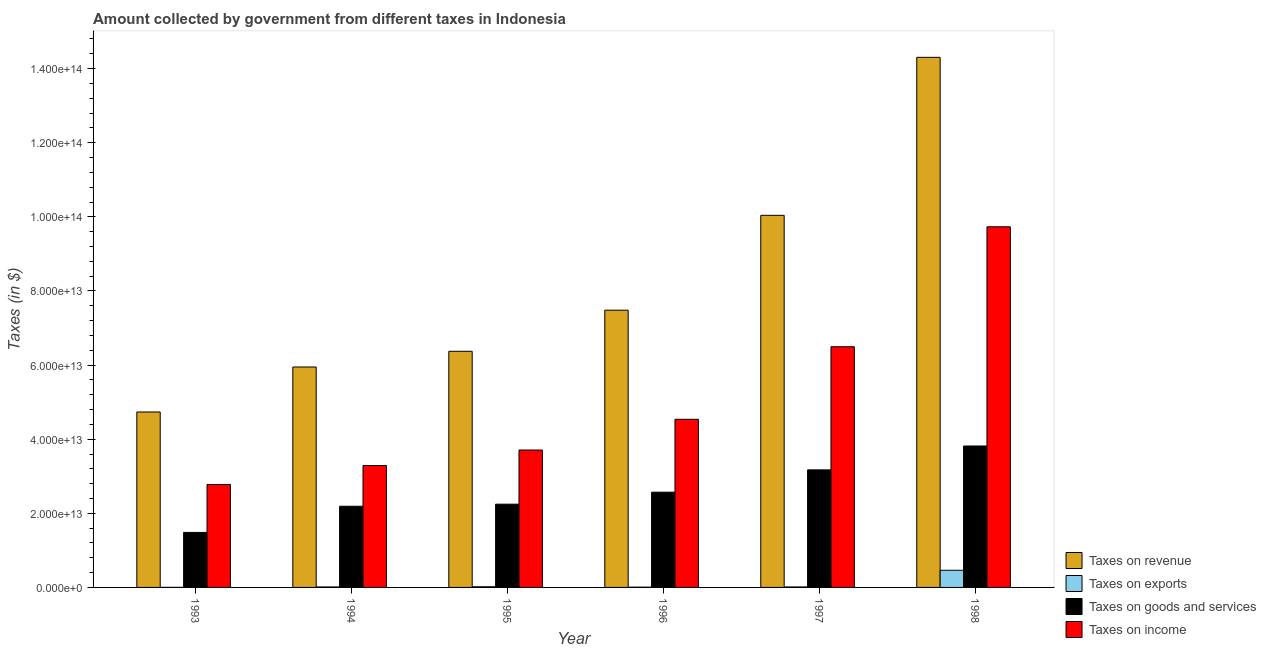How many bars are there on the 6th tick from the left?
Offer a terse response. 4. In how many cases, is the number of bars for a given year not equal to the number of legend labels?
Make the answer very short. 0. What is the amount collected as tax on income in 1994?
Keep it short and to the point. 3.29e+13. Across all years, what is the maximum amount collected as tax on revenue?
Offer a very short reply. 1.43e+14. Across all years, what is the minimum amount collected as tax on income?
Offer a terse response. 2.78e+13. What is the total amount collected as tax on goods in the graph?
Offer a very short reply. 1.55e+14. What is the difference between the amount collected as tax on revenue in 1996 and that in 1998?
Give a very brief answer. -6.82e+13. What is the difference between the amount collected as tax on goods in 1995 and the amount collected as tax on exports in 1998?
Ensure brevity in your answer.  -1.57e+13. What is the average amount collected as tax on income per year?
Offer a very short reply. 5.09e+13. In the year 1998, what is the difference between the amount collected as tax on exports and amount collected as tax on revenue?
Ensure brevity in your answer.  0. In how many years, is the amount collected as tax on revenue greater than 108000000000000 $?
Your answer should be very brief. 1. What is the ratio of the amount collected as tax on goods in 1993 to that in 1995?
Provide a short and direct response. 0.66. What is the difference between the highest and the second highest amount collected as tax on exports?
Keep it short and to the point. 4.44e+12. What is the difference between the highest and the lowest amount collected as tax on revenue?
Offer a terse response. 9.57e+13. Is the sum of the amount collected as tax on goods in 1993 and 1996 greater than the maximum amount collected as tax on income across all years?
Your response must be concise. Yes. Is it the case that in every year, the sum of the amount collected as tax on goods and amount collected as tax on revenue is greater than the sum of amount collected as tax on income and amount collected as tax on exports?
Offer a terse response. No. What does the 4th bar from the left in 1994 represents?
Make the answer very short. Taxes on income. What does the 3rd bar from the right in 1997 represents?
Your answer should be very brief. Taxes on exports. Is it the case that in every year, the sum of the amount collected as tax on revenue and amount collected as tax on exports is greater than the amount collected as tax on goods?
Offer a very short reply. Yes. How many bars are there?
Offer a terse response. 24. How many years are there in the graph?
Your answer should be very brief. 6. What is the difference between two consecutive major ticks on the Y-axis?
Your response must be concise. 2.00e+13. Are the values on the major ticks of Y-axis written in scientific E-notation?
Provide a short and direct response. Yes. Does the graph contain any zero values?
Provide a succinct answer. No. Does the graph contain grids?
Your answer should be compact. No. Where does the legend appear in the graph?
Ensure brevity in your answer.  Bottom right. How many legend labels are there?
Keep it short and to the point. 4. How are the legend labels stacked?
Make the answer very short. Vertical. What is the title of the graph?
Give a very brief answer. Amount collected by government from different taxes in Indonesia. What is the label or title of the Y-axis?
Offer a very short reply. Taxes (in $). What is the Taxes (in $) in Taxes on revenue in 1993?
Ensure brevity in your answer.  4.73e+13. What is the Taxes (in $) of Taxes on exports in 1993?
Your response must be concise. 1.40e+1. What is the Taxes (in $) of Taxes on goods and services in 1993?
Your answer should be compact. 1.48e+13. What is the Taxes (in $) of Taxes on income in 1993?
Your response must be concise. 2.78e+13. What is the Taxes (in $) in Taxes on revenue in 1994?
Ensure brevity in your answer.  5.95e+13. What is the Taxes (in $) of Taxes on exports in 1994?
Ensure brevity in your answer.  1.31e+11. What is the Taxes (in $) in Taxes on goods and services in 1994?
Provide a succinct answer. 2.19e+13. What is the Taxes (in $) of Taxes on income in 1994?
Keep it short and to the point. 3.29e+13. What is the Taxes (in $) of Taxes on revenue in 1995?
Offer a very short reply. 6.37e+13. What is the Taxes (in $) of Taxes on exports in 1995?
Keep it short and to the point. 1.86e+11. What is the Taxes (in $) of Taxes on goods and services in 1995?
Ensure brevity in your answer.  2.25e+13. What is the Taxes (in $) in Taxes on income in 1995?
Provide a succinct answer. 3.71e+13. What is the Taxes (in $) of Taxes on revenue in 1996?
Offer a terse response. 7.48e+13. What is the Taxes (in $) of Taxes on exports in 1996?
Make the answer very short. 7.00e+1. What is the Taxes (in $) of Taxes on goods and services in 1996?
Make the answer very short. 2.57e+13. What is the Taxes (in $) of Taxes on income in 1996?
Make the answer very short. 4.54e+13. What is the Taxes (in $) of Taxes on revenue in 1997?
Your response must be concise. 1.00e+14. What is the Taxes (in $) of Taxes on exports in 1997?
Your answer should be compact. 1.28e+11. What is the Taxes (in $) in Taxes on goods and services in 1997?
Give a very brief answer. 3.17e+13. What is the Taxes (in $) of Taxes on income in 1997?
Ensure brevity in your answer.  6.49e+13. What is the Taxes (in $) in Taxes on revenue in 1998?
Your response must be concise. 1.43e+14. What is the Taxes (in $) of Taxes on exports in 1998?
Make the answer very short. 4.63e+12. What is the Taxes (in $) in Taxes on goods and services in 1998?
Make the answer very short. 3.82e+13. What is the Taxes (in $) of Taxes on income in 1998?
Your response must be concise. 9.73e+13. Across all years, what is the maximum Taxes (in $) in Taxes on revenue?
Give a very brief answer. 1.43e+14. Across all years, what is the maximum Taxes (in $) in Taxes on exports?
Your response must be concise. 4.63e+12. Across all years, what is the maximum Taxes (in $) in Taxes on goods and services?
Ensure brevity in your answer.  3.82e+13. Across all years, what is the maximum Taxes (in $) in Taxes on income?
Offer a terse response. 9.73e+13. Across all years, what is the minimum Taxes (in $) of Taxes on revenue?
Your answer should be very brief. 4.73e+13. Across all years, what is the minimum Taxes (in $) in Taxes on exports?
Keep it short and to the point. 1.40e+1. Across all years, what is the minimum Taxes (in $) of Taxes on goods and services?
Provide a succinct answer. 1.48e+13. Across all years, what is the minimum Taxes (in $) of Taxes on income?
Make the answer very short. 2.78e+13. What is the total Taxes (in $) in Taxes on revenue in the graph?
Keep it short and to the point. 4.89e+14. What is the total Taxes (in $) in Taxes on exports in the graph?
Offer a very short reply. 5.16e+12. What is the total Taxes (in $) in Taxes on goods and services in the graph?
Offer a very short reply. 1.55e+14. What is the total Taxes (in $) in Taxes on income in the graph?
Your answer should be very brief. 3.05e+14. What is the difference between the Taxes (in $) in Taxes on revenue in 1993 and that in 1994?
Your response must be concise. -1.21e+13. What is the difference between the Taxes (in $) in Taxes on exports in 1993 and that in 1994?
Your answer should be compact. -1.17e+11. What is the difference between the Taxes (in $) in Taxes on goods and services in 1993 and that in 1994?
Provide a succinct answer. -7.06e+12. What is the difference between the Taxes (in $) of Taxes on income in 1993 and that in 1994?
Your answer should be very brief. -5.11e+12. What is the difference between the Taxes (in $) of Taxes on revenue in 1993 and that in 1995?
Offer a very short reply. -1.64e+13. What is the difference between the Taxes (in $) of Taxes on exports in 1993 and that in 1995?
Your answer should be compact. -1.72e+11. What is the difference between the Taxes (in $) of Taxes on goods and services in 1993 and that in 1995?
Your answer should be compact. -7.62e+12. What is the difference between the Taxes (in $) of Taxes on income in 1993 and that in 1995?
Keep it short and to the point. -9.30e+12. What is the difference between the Taxes (in $) of Taxes on revenue in 1993 and that in 1996?
Offer a very short reply. -2.75e+13. What is the difference between the Taxes (in $) of Taxes on exports in 1993 and that in 1996?
Keep it short and to the point. -5.60e+1. What is the difference between the Taxes (in $) of Taxes on goods and services in 1993 and that in 1996?
Provide a short and direct response. -1.09e+13. What is the difference between the Taxes (in $) in Taxes on income in 1993 and that in 1996?
Your response must be concise. -1.76e+13. What is the difference between the Taxes (in $) of Taxes on revenue in 1993 and that in 1997?
Make the answer very short. -5.31e+13. What is the difference between the Taxes (in $) in Taxes on exports in 1993 and that in 1997?
Your answer should be compact. -1.14e+11. What is the difference between the Taxes (in $) in Taxes on goods and services in 1993 and that in 1997?
Ensure brevity in your answer.  -1.69e+13. What is the difference between the Taxes (in $) of Taxes on income in 1993 and that in 1997?
Provide a succinct answer. -3.72e+13. What is the difference between the Taxes (in $) in Taxes on revenue in 1993 and that in 1998?
Provide a short and direct response. -9.57e+13. What is the difference between the Taxes (in $) of Taxes on exports in 1993 and that in 1998?
Your answer should be compact. -4.62e+12. What is the difference between the Taxes (in $) in Taxes on goods and services in 1993 and that in 1998?
Your response must be concise. -2.33e+13. What is the difference between the Taxes (in $) of Taxes on income in 1993 and that in 1998?
Make the answer very short. -6.95e+13. What is the difference between the Taxes (in $) of Taxes on revenue in 1994 and that in 1995?
Your response must be concise. -4.24e+12. What is the difference between the Taxes (in $) of Taxes on exports in 1994 and that in 1995?
Provide a short and direct response. -5.50e+1. What is the difference between the Taxes (in $) of Taxes on goods and services in 1994 and that in 1995?
Offer a terse response. -5.60e+11. What is the difference between the Taxes (in $) in Taxes on income in 1994 and that in 1995?
Ensure brevity in your answer.  -4.18e+12. What is the difference between the Taxes (in $) in Taxes on revenue in 1994 and that in 1996?
Provide a short and direct response. -1.53e+13. What is the difference between the Taxes (in $) in Taxes on exports in 1994 and that in 1996?
Provide a short and direct response. 6.10e+1. What is the difference between the Taxes (in $) in Taxes on goods and services in 1994 and that in 1996?
Make the answer very short. -3.80e+12. What is the difference between the Taxes (in $) in Taxes on income in 1994 and that in 1996?
Offer a terse response. -1.25e+13. What is the difference between the Taxes (in $) in Taxes on revenue in 1994 and that in 1997?
Your response must be concise. -4.09e+13. What is the difference between the Taxes (in $) in Taxes on exports in 1994 and that in 1997?
Your answer should be very brief. 2.50e+09. What is the difference between the Taxes (in $) in Taxes on goods and services in 1994 and that in 1997?
Make the answer very short. -9.82e+12. What is the difference between the Taxes (in $) of Taxes on income in 1994 and that in 1997?
Ensure brevity in your answer.  -3.21e+13. What is the difference between the Taxes (in $) in Taxes on revenue in 1994 and that in 1998?
Your answer should be compact. -8.36e+13. What is the difference between the Taxes (in $) in Taxes on exports in 1994 and that in 1998?
Your response must be concise. -4.50e+12. What is the difference between the Taxes (in $) of Taxes on goods and services in 1994 and that in 1998?
Provide a short and direct response. -1.63e+13. What is the difference between the Taxes (in $) in Taxes on income in 1994 and that in 1998?
Offer a terse response. -6.44e+13. What is the difference between the Taxes (in $) of Taxes on revenue in 1995 and that in 1996?
Your answer should be very brief. -1.11e+13. What is the difference between the Taxes (in $) of Taxes on exports in 1995 and that in 1996?
Give a very brief answer. 1.16e+11. What is the difference between the Taxes (in $) in Taxes on goods and services in 1995 and that in 1996?
Provide a short and direct response. -3.24e+12. What is the difference between the Taxes (in $) of Taxes on income in 1995 and that in 1996?
Give a very brief answer. -8.29e+12. What is the difference between the Taxes (in $) of Taxes on revenue in 1995 and that in 1997?
Your answer should be compact. -3.67e+13. What is the difference between the Taxes (in $) in Taxes on exports in 1995 and that in 1997?
Your answer should be compact. 5.75e+1. What is the difference between the Taxes (in $) in Taxes on goods and services in 1995 and that in 1997?
Make the answer very short. -9.26e+12. What is the difference between the Taxes (in $) in Taxes on income in 1995 and that in 1997?
Provide a short and direct response. -2.79e+13. What is the difference between the Taxes (in $) of Taxes on revenue in 1995 and that in 1998?
Provide a short and direct response. -7.93e+13. What is the difference between the Taxes (in $) of Taxes on exports in 1995 and that in 1998?
Provide a short and direct response. -4.44e+12. What is the difference between the Taxes (in $) in Taxes on goods and services in 1995 and that in 1998?
Keep it short and to the point. -1.57e+13. What is the difference between the Taxes (in $) in Taxes on income in 1995 and that in 1998?
Your answer should be compact. -6.02e+13. What is the difference between the Taxes (in $) in Taxes on revenue in 1996 and that in 1997?
Offer a very short reply. -2.56e+13. What is the difference between the Taxes (in $) in Taxes on exports in 1996 and that in 1997?
Provide a succinct answer. -5.85e+1. What is the difference between the Taxes (in $) in Taxes on goods and services in 1996 and that in 1997?
Make the answer very short. -6.02e+12. What is the difference between the Taxes (in $) in Taxes on income in 1996 and that in 1997?
Ensure brevity in your answer.  -1.96e+13. What is the difference between the Taxes (in $) of Taxes on revenue in 1996 and that in 1998?
Make the answer very short. -6.82e+13. What is the difference between the Taxes (in $) in Taxes on exports in 1996 and that in 1998?
Offer a very short reply. -4.56e+12. What is the difference between the Taxes (in $) in Taxes on goods and services in 1996 and that in 1998?
Provide a succinct answer. -1.25e+13. What is the difference between the Taxes (in $) in Taxes on income in 1996 and that in 1998?
Provide a short and direct response. -5.19e+13. What is the difference between the Taxes (in $) of Taxes on revenue in 1997 and that in 1998?
Offer a very short reply. -4.26e+13. What is the difference between the Taxes (in $) of Taxes on exports in 1997 and that in 1998?
Your response must be concise. -4.50e+12. What is the difference between the Taxes (in $) in Taxes on goods and services in 1997 and that in 1998?
Your response must be concise. -6.44e+12. What is the difference between the Taxes (in $) of Taxes on income in 1997 and that in 1998?
Offer a terse response. -3.24e+13. What is the difference between the Taxes (in $) in Taxes on revenue in 1993 and the Taxes (in $) in Taxes on exports in 1994?
Provide a succinct answer. 4.72e+13. What is the difference between the Taxes (in $) of Taxes on revenue in 1993 and the Taxes (in $) of Taxes on goods and services in 1994?
Your answer should be compact. 2.54e+13. What is the difference between the Taxes (in $) in Taxes on revenue in 1993 and the Taxes (in $) in Taxes on income in 1994?
Offer a very short reply. 1.44e+13. What is the difference between the Taxes (in $) in Taxes on exports in 1993 and the Taxes (in $) in Taxes on goods and services in 1994?
Offer a terse response. -2.19e+13. What is the difference between the Taxes (in $) of Taxes on exports in 1993 and the Taxes (in $) of Taxes on income in 1994?
Make the answer very short. -3.29e+13. What is the difference between the Taxes (in $) of Taxes on goods and services in 1993 and the Taxes (in $) of Taxes on income in 1994?
Your answer should be very brief. -1.81e+13. What is the difference between the Taxes (in $) in Taxes on revenue in 1993 and the Taxes (in $) in Taxes on exports in 1995?
Offer a very short reply. 4.72e+13. What is the difference between the Taxes (in $) in Taxes on revenue in 1993 and the Taxes (in $) in Taxes on goods and services in 1995?
Offer a very short reply. 2.49e+13. What is the difference between the Taxes (in $) in Taxes on revenue in 1993 and the Taxes (in $) in Taxes on income in 1995?
Provide a short and direct response. 1.03e+13. What is the difference between the Taxes (in $) of Taxes on exports in 1993 and the Taxes (in $) of Taxes on goods and services in 1995?
Ensure brevity in your answer.  -2.25e+13. What is the difference between the Taxes (in $) of Taxes on exports in 1993 and the Taxes (in $) of Taxes on income in 1995?
Keep it short and to the point. -3.71e+13. What is the difference between the Taxes (in $) of Taxes on goods and services in 1993 and the Taxes (in $) of Taxes on income in 1995?
Ensure brevity in your answer.  -2.22e+13. What is the difference between the Taxes (in $) of Taxes on revenue in 1993 and the Taxes (in $) of Taxes on exports in 1996?
Your answer should be very brief. 4.73e+13. What is the difference between the Taxes (in $) in Taxes on revenue in 1993 and the Taxes (in $) in Taxes on goods and services in 1996?
Your response must be concise. 2.16e+13. What is the difference between the Taxes (in $) in Taxes on revenue in 1993 and the Taxes (in $) in Taxes on income in 1996?
Give a very brief answer. 1.98e+12. What is the difference between the Taxes (in $) in Taxes on exports in 1993 and the Taxes (in $) in Taxes on goods and services in 1996?
Provide a short and direct response. -2.57e+13. What is the difference between the Taxes (in $) in Taxes on exports in 1993 and the Taxes (in $) in Taxes on income in 1996?
Offer a terse response. -4.54e+13. What is the difference between the Taxes (in $) of Taxes on goods and services in 1993 and the Taxes (in $) of Taxes on income in 1996?
Offer a very short reply. -3.05e+13. What is the difference between the Taxes (in $) of Taxes on revenue in 1993 and the Taxes (in $) of Taxes on exports in 1997?
Your response must be concise. 4.72e+13. What is the difference between the Taxes (in $) of Taxes on revenue in 1993 and the Taxes (in $) of Taxes on goods and services in 1997?
Keep it short and to the point. 1.56e+13. What is the difference between the Taxes (in $) in Taxes on revenue in 1993 and the Taxes (in $) in Taxes on income in 1997?
Your answer should be compact. -1.76e+13. What is the difference between the Taxes (in $) of Taxes on exports in 1993 and the Taxes (in $) of Taxes on goods and services in 1997?
Provide a short and direct response. -3.17e+13. What is the difference between the Taxes (in $) of Taxes on exports in 1993 and the Taxes (in $) of Taxes on income in 1997?
Your answer should be compact. -6.49e+13. What is the difference between the Taxes (in $) of Taxes on goods and services in 1993 and the Taxes (in $) of Taxes on income in 1997?
Provide a succinct answer. -5.01e+13. What is the difference between the Taxes (in $) in Taxes on revenue in 1993 and the Taxes (in $) in Taxes on exports in 1998?
Offer a very short reply. 4.27e+13. What is the difference between the Taxes (in $) in Taxes on revenue in 1993 and the Taxes (in $) in Taxes on goods and services in 1998?
Your response must be concise. 9.18e+12. What is the difference between the Taxes (in $) of Taxes on revenue in 1993 and the Taxes (in $) of Taxes on income in 1998?
Give a very brief answer. -5.00e+13. What is the difference between the Taxes (in $) of Taxes on exports in 1993 and the Taxes (in $) of Taxes on goods and services in 1998?
Provide a succinct answer. -3.81e+13. What is the difference between the Taxes (in $) of Taxes on exports in 1993 and the Taxes (in $) of Taxes on income in 1998?
Your response must be concise. -9.73e+13. What is the difference between the Taxes (in $) of Taxes on goods and services in 1993 and the Taxes (in $) of Taxes on income in 1998?
Keep it short and to the point. -8.25e+13. What is the difference between the Taxes (in $) in Taxes on revenue in 1994 and the Taxes (in $) in Taxes on exports in 1995?
Make the answer very short. 5.93e+13. What is the difference between the Taxes (in $) in Taxes on revenue in 1994 and the Taxes (in $) in Taxes on goods and services in 1995?
Provide a succinct answer. 3.70e+13. What is the difference between the Taxes (in $) of Taxes on revenue in 1994 and the Taxes (in $) of Taxes on income in 1995?
Your answer should be very brief. 2.24e+13. What is the difference between the Taxes (in $) of Taxes on exports in 1994 and the Taxes (in $) of Taxes on goods and services in 1995?
Offer a very short reply. -2.23e+13. What is the difference between the Taxes (in $) in Taxes on exports in 1994 and the Taxes (in $) in Taxes on income in 1995?
Ensure brevity in your answer.  -3.69e+13. What is the difference between the Taxes (in $) of Taxes on goods and services in 1994 and the Taxes (in $) of Taxes on income in 1995?
Ensure brevity in your answer.  -1.52e+13. What is the difference between the Taxes (in $) in Taxes on revenue in 1994 and the Taxes (in $) in Taxes on exports in 1996?
Ensure brevity in your answer.  5.94e+13. What is the difference between the Taxes (in $) in Taxes on revenue in 1994 and the Taxes (in $) in Taxes on goods and services in 1996?
Make the answer very short. 3.38e+13. What is the difference between the Taxes (in $) in Taxes on revenue in 1994 and the Taxes (in $) in Taxes on income in 1996?
Your response must be concise. 1.41e+13. What is the difference between the Taxes (in $) of Taxes on exports in 1994 and the Taxes (in $) of Taxes on goods and services in 1996?
Offer a very short reply. -2.56e+13. What is the difference between the Taxes (in $) in Taxes on exports in 1994 and the Taxes (in $) in Taxes on income in 1996?
Your response must be concise. -4.52e+13. What is the difference between the Taxes (in $) of Taxes on goods and services in 1994 and the Taxes (in $) of Taxes on income in 1996?
Offer a very short reply. -2.35e+13. What is the difference between the Taxes (in $) in Taxes on revenue in 1994 and the Taxes (in $) in Taxes on exports in 1997?
Ensure brevity in your answer.  5.94e+13. What is the difference between the Taxes (in $) of Taxes on revenue in 1994 and the Taxes (in $) of Taxes on goods and services in 1997?
Your answer should be very brief. 2.78e+13. What is the difference between the Taxes (in $) in Taxes on revenue in 1994 and the Taxes (in $) in Taxes on income in 1997?
Your answer should be very brief. -5.47e+12. What is the difference between the Taxes (in $) in Taxes on exports in 1994 and the Taxes (in $) in Taxes on goods and services in 1997?
Provide a short and direct response. -3.16e+13. What is the difference between the Taxes (in $) of Taxes on exports in 1994 and the Taxes (in $) of Taxes on income in 1997?
Give a very brief answer. -6.48e+13. What is the difference between the Taxes (in $) of Taxes on goods and services in 1994 and the Taxes (in $) of Taxes on income in 1997?
Ensure brevity in your answer.  -4.30e+13. What is the difference between the Taxes (in $) of Taxes on revenue in 1994 and the Taxes (in $) of Taxes on exports in 1998?
Your answer should be compact. 5.49e+13. What is the difference between the Taxes (in $) of Taxes on revenue in 1994 and the Taxes (in $) of Taxes on goods and services in 1998?
Give a very brief answer. 2.13e+13. What is the difference between the Taxes (in $) of Taxes on revenue in 1994 and the Taxes (in $) of Taxes on income in 1998?
Your answer should be compact. -3.78e+13. What is the difference between the Taxes (in $) of Taxes on exports in 1994 and the Taxes (in $) of Taxes on goods and services in 1998?
Offer a terse response. -3.80e+13. What is the difference between the Taxes (in $) in Taxes on exports in 1994 and the Taxes (in $) in Taxes on income in 1998?
Give a very brief answer. -9.72e+13. What is the difference between the Taxes (in $) in Taxes on goods and services in 1994 and the Taxes (in $) in Taxes on income in 1998?
Offer a terse response. -7.54e+13. What is the difference between the Taxes (in $) in Taxes on revenue in 1995 and the Taxes (in $) in Taxes on exports in 1996?
Provide a succinct answer. 6.36e+13. What is the difference between the Taxes (in $) in Taxes on revenue in 1995 and the Taxes (in $) in Taxes on goods and services in 1996?
Make the answer very short. 3.80e+13. What is the difference between the Taxes (in $) of Taxes on revenue in 1995 and the Taxes (in $) of Taxes on income in 1996?
Your response must be concise. 1.84e+13. What is the difference between the Taxes (in $) in Taxes on exports in 1995 and the Taxes (in $) in Taxes on goods and services in 1996?
Your answer should be compact. -2.55e+13. What is the difference between the Taxes (in $) in Taxes on exports in 1995 and the Taxes (in $) in Taxes on income in 1996?
Offer a very short reply. -4.52e+13. What is the difference between the Taxes (in $) of Taxes on goods and services in 1995 and the Taxes (in $) of Taxes on income in 1996?
Keep it short and to the point. -2.29e+13. What is the difference between the Taxes (in $) in Taxes on revenue in 1995 and the Taxes (in $) in Taxes on exports in 1997?
Make the answer very short. 6.36e+13. What is the difference between the Taxes (in $) in Taxes on revenue in 1995 and the Taxes (in $) in Taxes on goods and services in 1997?
Your answer should be compact. 3.20e+13. What is the difference between the Taxes (in $) in Taxes on revenue in 1995 and the Taxes (in $) in Taxes on income in 1997?
Your response must be concise. -1.23e+12. What is the difference between the Taxes (in $) of Taxes on exports in 1995 and the Taxes (in $) of Taxes on goods and services in 1997?
Ensure brevity in your answer.  -3.15e+13. What is the difference between the Taxes (in $) of Taxes on exports in 1995 and the Taxes (in $) of Taxes on income in 1997?
Keep it short and to the point. -6.48e+13. What is the difference between the Taxes (in $) in Taxes on goods and services in 1995 and the Taxes (in $) in Taxes on income in 1997?
Your answer should be compact. -4.25e+13. What is the difference between the Taxes (in $) of Taxes on revenue in 1995 and the Taxes (in $) of Taxes on exports in 1998?
Offer a very short reply. 5.91e+13. What is the difference between the Taxes (in $) of Taxes on revenue in 1995 and the Taxes (in $) of Taxes on goods and services in 1998?
Ensure brevity in your answer.  2.56e+13. What is the difference between the Taxes (in $) of Taxes on revenue in 1995 and the Taxes (in $) of Taxes on income in 1998?
Your response must be concise. -3.36e+13. What is the difference between the Taxes (in $) in Taxes on exports in 1995 and the Taxes (in $) in Taxes on goods and services in 1998?
Make the answer very short. -3.80e+13. What is the difference between the Taxes (in $) of Taxes on exports in 1995 and the Taxes (in $) of Taxes on income in 1998?
Offer a very short reply. -9.71e+13. What is the difference between the Taxes (in $) of Taxes on goods and services in 1995 and the Taxes (in $) of Taxes on income in 1998?
Your answer should be very brief. -7.48e+13. What is the difference between the Taxes (in $) in Taxes on revenue in 1996 and the Taxes (in $) in Taxes on exports in 1997?
Your answer should be very brief. 7.47e+13. What is the difference between the Taxes (in $) in Taxes on revenue in 1996 and the Taxes (in $) in Taxes on goods and services in 1997?
Your response must be concise. 4.31e+13. What is the difference between the Taxes (in $) of Taxes on revenue in 1996 and the Taxes (in $) of Taxes on income in 1997?
Provide a succinct answer. 9.86e+12. What is the difference between the Taxes (in $) of Taxes on exports in 1996 and the Taxes (in $) of Taxes on goods and services in 1997?
Keep it short and to the point. -3.17e+13. What is the difference between the Taxes (in $) of Taxes on exports in 1996 and the Taxes (in $) of Taxes on income in 1997?
Keep it short and to the point. -6.49e+13. What is the difference between the Taxes (in $) in Taxes on goods and services in 1996 and the Taxes (in $) in Taxes on income in 1997?
Your response must be concise. -3.92e+13. What is the difference between the Taxes (in $) in Taxes on revenue in 1996 and the Taxes (in $) in Taxes on exports in 1998?
Your response must be concise. 7.02e+13. What is the difference between the Taxes (in $) in Taxes on revenue in 1996 and the Taxes (in $) in Taxes on goods and services in 1998?
Provide a short and direct response. 3.66e+13. What is the difference between the Taxes (in $) in Taxes on revenue in 1996 and the Taxes (in $) in Taxes on income in 1998?
Keep it short and to the point. -2.25e+13. What is the difference between the Taxes (in $) of Taxes on exports in 1996 and the Taxes (in $) of Taxes on goods and services in 1998?
Your answer should be compact. -3.81e+13. What is the difference between the Taxes (in $) in Taxes on exports in 1996 and the Taxes (in $) in Taxes on income in 1998?
Ensure brevity in your answer.  -9.72e+13. What is the difference between the Taxes (in $) in Taxes on goods and services in 1996 and the Taxes (in $) in Taxes on income in 1998?
Give a very brief answer. -7.16e+13. What is the difference between the Taxes (in $) in Taxes on revenue in 1997 and the Taxes (in $) in Taxes on exports in 1998?
Your answer should be very brief. 9.58e+13. What is the difference between the Taxes (in $) in Taxes on revenue in 1997 and the Taxes (in $) in Taxes on goods and services in 1998?
Provide a succinct answer. 6.22e+13. What is the difference between the Taxes (in $) of Taxes on revenue in 1997 and the Taxes (in $) of Taxes on income in 1998?
Ensure brevity in your answer.  3.10e+12. What is the difference between the Taxes (in $) of Taxes on exports in 1997 and the Taxes (in $) of Taxes on goods and services in 1998?
Ensure brevity in your answer.  -3.80e+13. What is the difference between the Taxes (in $) in Taxes on exports in 1997 and the Taxes (in $) in Taxes on income in 1998?
Your response must be concise. -9.72e+13. What is the difference between the Taxes (in $) in Taxes on goods and services in 1997 and the Taxes (in $) in Taxes on income in 1998?
Provide a short and direct response. -6.56e+13. What is the average Taxes (in $) of Taxes on revenue per year?
Keep it short and to the point. 8.15e+13. What is the average Taxes (in $) in Taxes on exports per year?
Make the answer very short. 8.60e+11. What is the average Taxes (in $) in Taxes on goods and services per year?
Your response must be concise. 2.58e+13. What is the average Taxes (in $) of Taxes on income per year?
Provide a succinct answer. 5.09e+13. In the year 1993, what is the difference between the Taxes (in $) of Taxes on revenue and Taxes (in $) of Taxes on exports?
Give a very brief answer. 4.73e+13. In the year 1993, what is the difference between the Taxes (in $) of Taxes on revenue and Taxes (in $) of Taxes on goods and services?
Ensure brevity in your answer.  3.25e+13. In the year 1993, what is the difference between the Taxes (in $) in Taxes on revenue and Taxes (in $) in Taxes on income?
Your response must be concise. 1.96e+13. In the year 1993, what is the difference between the Taxes (in $) in Taxes on exports and Taxes (in $) in Taxes on goods and services?
Your answer should be very brief. -1.48e+13. In the year 1993, what is the difference between the Taxes (in $) in Taxes on exports and Taxes (in $) in Taxes on income?
Your answer should be very brief. -2.78e+13. In the year 1993, what is the difference between the Taxes (in $) in Taxes on goods and services and Taxes (in $) in Taxes on income?
Provide a succinct answer. -1.29e+13. In the year 1994, what is the difference between the Taxes (in $) of Taxes on revenue and Taxes (in $) of Taxes on exports?
Your response must be concise. 5.94e+13. In the year 1994, what is the difference between the Taxes (in $) of Taxes on revenue and Taxes (in $) of Taxes on goods and services?
Give a very brief answer. 3.76e+13. In the year 1994, what is the difference between the Taxes (in $) in Taxes on revenue and Taxes (in $) in Taxes on income?
Your answer should be compact. 2.66e+13. In the year 1994, what is the difference between the Taxes (in $) of Taxes on exports and Taxes (in $) of Taxes on goods and services?
Ensure brevity in your answer.  -2.18e+13. In the year 1994, what is the difference between the Taxes (in $) of Taxes on exports and Taxes (in $) of Taxes on income?
Offer a terse response. -3.28e+13. In the year 1994, what is the difference between the Taxes (in $) in Taxes on goods and services and Taxes (in $) in Taxes on income?
Your answer should be very brief. -1.10e+13. In the year 1995, what is the difference between the Taxes (in $) of Taxes on revenue and Taxes (in $) of Taxes on exports?
Keep it short and to the point. 6.35e+13. In the year 1995, what is the difference between the Taxes (in $) of Taxes on revenue and Taxes (in $) of Taxes on goods and services?
Ensure brevity in your answer.  4.13e+13. In the year 1995, what is the difference between the Taxes (in $) of Taxes on revenue and Taxes (in $) of Taxes on income?
Offer a terse response. 2.66e+13. In the year 1995, what is the difference between the Taxes (in $) in Taxes on exports and Taxes (in $) in Taxes on goods and services?
Your answer should be very brief. -2.23e+13. In the year 1995, what is the difference between the Taxes (in $) in Taxes on exports and Taxes (in $) in Taxes on income?
Your response must be concise. -3.69e+13. In the year 1995, what is the difference between the Taxes (in $) of Taxes on goods and services and Taxes (in $) of Taxes on income?
Keep it short and to the point. -1.46e+13. In the year 1996, what is the difference between the Taxes (in $) of Taxes on revenue and Taxes (in $) of Taxes on exports?
Provide a succinct answer. 7.47e+13. In the year 1996, what is the difference between the Taxes (in $) in Taxes on revenue and Taxes (in $) in Taxes on goods and services?
Make the answer very short. 4.91e+13. In the year 1996, what is the difference between the Taxes (in $) in Taxes on revenue and Taxes (in $) in Taxes on income?
Your answer should be very brief. 2.94e+13. In the year 1996, what is the difference between the Taxes (in $) in Taxes on exports and Taxes (in $) in Taxes on goods and services?
Provide a succinct answer. -2.56e+13. In the year 1996, what is the difference between the Taxes (in $) in Taxes on exports and Taxes (in $) in Taxes on income?
Provide a short and direct response. -4.53e+13. In the year 1996, what is the difference between the Taxes (in $) in Taxes on goods and services and Taxes (in $) in Taxes on income?
Give a very brief answer. -1.97e+13. In the year 1997, what is the difference between the Taxes (in $) in Taxes on revenue and Taxes (in $) in Taxes on exports?
Provide a short and direct response. 1.00e+14. In the year 1997, what is the difference between the Taxes (in $) of Taxes on revenue and Taxes (in $) of Taxes on goods and services?
Provide a succinct answer. 6.87e+13. In the year 1997, what is the difference between the Taxes (in $) of Taxes on revenue and Taxes (in $) of Taxes on income?
Offer a very short reply. 3.55e+13. In the year 1997, what is the difference between the Taxes (in $) in Taxes on exports and Taxes (in $) in Taxes on goods and services?
Your answer should be compact. -3.16e+13. In the year 1997, what is the difference between the Taxes (in $) in Taxes on exports and Taxes (in $) in Taxes on income?
Ensure brevity in your answer.  -6.48e+13. In the year 1997, what is the difference between the Taxes (in $) of Taxes on goods and services and Taxes (in $) of Taxes on income?
Provide a succinct answer. -3.32e+13. In the year 1998, what is the difference between the Taxes (in $) in Taxes on revenue and Taxes (in $) in Taxes on exports?
Ensure brevity in your answer.  1.38e+14. In the year 1998, what is the difference between the Taxes (in $) in Taxes on revenue and Taxes (in $) in Taxes on goods and services?
Your answer should be very brief. 1.05e+14. In the year 1998, what is the difference between the Taxes (in $) of Taxes on revenue and Taxes (in $) of Taxes on income?
Ensure brevity in your answer.  4.57e+13. In the year 1998, what is the difference between the Taxes (in $) of Taxes on exports and Taxes (in $) of Taxes on goods and services?
Offer a terse response. -3.35e+13. In the year 1998, what is the difference between the Taxes (in $) in Taxes on exports and Taxes (in $) in Taxes on income?
Offer a very short reply. -9.27e+13. In the year 1998, what is the difference between the Taxes (in $) of Taxes on goods and services and Taxes (in $) of Taxes on income?
Provide a succinct answer. -5.92e+13. What is the ratio of the Taxes (in $) of Taxes on revenue in 1993 to that in 1994?
Provide a short and direct response. 0.8. What is the ratio of the Taxes (in $) of Taxes on exports in 1993 to that in 1994?
Ensure brevity in your answer.  0.11. What is the ratio of the Taxes (in $) in Taxes on goods and services in 1993 to that in 1994?
Make the answer very short. 0.68. What is the ratio of the Taxes (in $) of Taxes on income in 1993 to that in 1994?
Provide a succinct answer. 0.84. What is the ratio of the Taxes (in $) of Taxes on revenue in 1993 to that in 1995?
Ensure brevity in your answer.  0.74. What is the ratio of the Taxes (in $) of Taxes on exports in 1993 to that in 1995?
Your answer should be compact. 0.08. What is the ratio of the Taxes (in $) of Taxes on goods and services in 1993 to that in 1995?
Offer a very short reply. 0.66. What is the ratio of the Taxes (in $) in Taxes on income in 1993 to that in 1995?
Provide a succinct answer. 0.75. What is the ratio of the Taxes (in $) of Taxes on revenue in 1993 to that in 1996?
Provide a succinct answer. 0.63. What is the ratio of the Taxes (in $) of Taxes on goods and services in 1993 to that in 1996?
Your response must be concise. 0.58. What is the ratio of the Taxes (in $) of Taxes on income in 1993 to that in 1996?
Offer a terse response. 0.61. What is the ratio of the Taxes (in $) in Taxes on revenue in 1993 to that in 1997?
Your answer should be compact. 0.47. What is the ratio of the Taxes (in $) of Taxes on exports in 1993 to that in 1997?
Provide a succinct answer. 0.11. What is the ratio of the Taxes (in $) in Taxes on goods and services in 1993 to that in 1997?
Ensure brevity in your answer.  0.47. What is the ratio of the Taxes (in $) of Taxes on income in 1993 to that in 1997?
Keep it short and to the point. 0.43. What is the ratio of the Taxes (in $) of Taxes on revenue in 1993 to that in 1998?
Give a very brief answer. 0.33. What is the ratio of the Taxes (in $) of Taxes on exports in 1993 to that in 1998?
Your answer should be very brief. 0. What is the ratio of the Taxes (in $) of Taxes on goods and services in 1993 to that in 1998?
Your response must be concise. 0.39. What is the ratio of the Taxes (in $) in Taxes on income in 1993 to that in 1998?
Make the answer very short. 0.29. What is the ratio of the Taxes (in $) in Taxes on revenue in 1994 to that in 1995?
Your response must be concise. 0.93. What is the ratio of the Taxes (in $) in Taxes on exports in 1994 to that in 1995?
Give a very brief answer. 0.7. What is the ratio of the Taxes (in $) of Taxes on goods and services in 1994 to that in 1995?
Ensure brevity in your answer.  0.98. What is the ratio of the Taxes (in $) of Taxes on income in 1994 to that in 1995?
Your response must be concise. 0.89. What is the ratio of the Taxes (in $) in Taxes on revenue in 1994 to that in 1996?
Give a very brief answer. 0.8. What is the ratio of the Taxes (in $) of Taxes on exports in 1994 to that in 1996?
Provide a short and direct response. 1.87. What is the ratio of the Taxes (in $) in Taxes on goods and services in 1994 to that in 1996?
Provide a succinct answer. 0.85. What is the ratio of the Taxes (in $) of Taxes on income in 1994 to that in 1996?
Give a very brief answer. 0.73. What is the ratio of the Taxes (in $) in Taxes on revenue in 1994 to that in 1997?
Offer a terse response. 0.59. What is the ratio of the Taxes (in $) in Taxes on exports in 1994 to that in 1997?
Your answer should be compact. 1.02. What is the ratio of the Taxes (in $) in Taxes on goods and services in 1994 to that in 1997?
Your response must be concise. 0.69. What is the ratio of the Taxes (in $) in Taxes on income in 1994 to that in 1997?
Provide a short and direct response. 0.51. What is the ratio of the Taxes (in $) of Taxes on revenue in 1994 to that in 1998?
Provide a succinct answer. 0.42. What is the ratio of the Taxes (in $) of Taxes on exports in 1994 to that in 1998?
Provide a short and direct response. 0.03. What is the ratio of the Taxes (in $) in Taxes on goods and services in 1994 to that in 1998?
Give a very brief answer. 0.57. What is the ratio of the Taxes (in $) in Taxes on income in 1994 to that in 1998?
Offer a terse response. 0.34. What is the ratio of the Taxes (in $) in Taxes on revenue in 1995 to that in 1996?
Your answer should be compact. 0.85. What is the ratio of the Taxes (in $) of Taxes on exports in 1995 to that in 1996?
Ensure brevity in your answer.  2.66. What is the ratio of the Taxes (in $) in Taxes on goods and services in 1995 to that in 1996?
Provide a succinct answer. 0.87. What is the ratio of the Taxes (in $) of Taxes on income in 1995 to that in 1996?
Your answer should be very brief. 0.82. What is the ratio of the Taxes (in $) in Taxes on revenue in 1995 to that in 1997?
Offer a terse response. 0.63. What is the ratio of the Taxes (in $) of Taxes on exports in 1995 to that in 1997?
Your answer should be compact. 1.45. What is the ratio of the Taxes (in $) in Taxes on goods and services in 1995 to that in 1997?
Provide a succinct answer. 0.71. What is the ratio of the Taxes (in $) of Taxes on income in 1995 to that in 1997?
Provide a succinct answer. 0.57. What is the ratio of the Taxes (in $) in Taxes on revenue in 1995 to that in 1998?
Ensure brevity in your answer.  0.45. What is the ratio of the Taxes (in $) in Taxes on exports in 1995 to that in 1998?
Your response must be concise. 0.04. What is the ratio of the Taxes (in $) in Taxes on goods and services in 1995 to that in 1998?
Make the answer very short. 0.59. What is the ratio of the Taxes (in $) of Taxes on income in 1995 to that in 1998?
Offer a terse response. 0.38. What is the ratio of the Taxes (in $) of Taxes on revenue in 1996 to that in 1997?
Keep it short and to the point. 0.75. What is the ratio of the Taxes (in $) in Taxes on exports in 1996 to that in 1997?
Offer a very short reply. 0.54. What is the ratio of the Taxes (in $) of Taxes on goods and services in 1996 to that in 1997?
Your answer should be compact. 0.81. What is the ratio of the Taxes (in $) of Taxes on income in 1996 to that in 1997?
Provide a short and direct response. 0.7. What is the ratio of the Taxes (in $) in Taxes on revenue in 1996 to that in 1998?
Keep it short and to the point. 0.52. What is the ratio of the Taxes (in $) of Taxes on exports in 1996 to that in 1998?
Give a very brief answer. 0.02. What is the ratio of the Taxes (in $) of Taxes on goods and services in 1996 to that in 1998?
Provide a succinct answer. 0.67. What is the ratio of the Taxes (in $) in Taxes on income in 1996 to that in 1998?
Offer a terse response. 0.47. What is the ratio of the Taxes (in $) of Taxes on revenue in 1997 to that in 1998?
Offer a very short reply. 0.7. What is the ratio of the Taxes (in $) of Taxes on exports in 1997 to that in 1998?
Provide a short and direct response. 0.03. What is the ratio of the Taxes (in $) in Taxes on goods and services in 1997 to that in 1998?
Give a very brief answer. 0.83. What is the ratio of the Taxes (in $) in Taxes on income in 1997 to that in 1998?
Your response must be concise. 0.67. What is the difference between the highest and the second highest Taxes (in $) in Taxes on revenue?
Provide a succinct answer. 4.26e+13. What is the difference between the highest and the second highest Taxes (in $) in Taxes on exports?
Ensure brevity in your answer.  4.44e+12. What is the difference between the highest and the second highest Taxes (in $) in Taxes on goods and services?
Your response must be concise. 6.44e+12. What is the difference between the highest and the second highest Taxes (in $) in Taxes on income?
Provide a short and direct response. 3.24e+13. What is the difference between the highest and the lowest Taxes (in $) in Taxes on revenue?
Keep it short and to the point. 9.57e+13. What is the difference between the highest and the lowest Taxes (in $) of Taxes on exports?
Your answer should be compact. 4.62e+12. What is the difference between the highest and the lowest Taxes (in $) of Taxes on goods and services?
Offer a terse response. 2.33e+13. What is the difference between the highest and the lowest Taxes (in $) of Taxes on income?
Your response must be concise. 6.95e+13. 